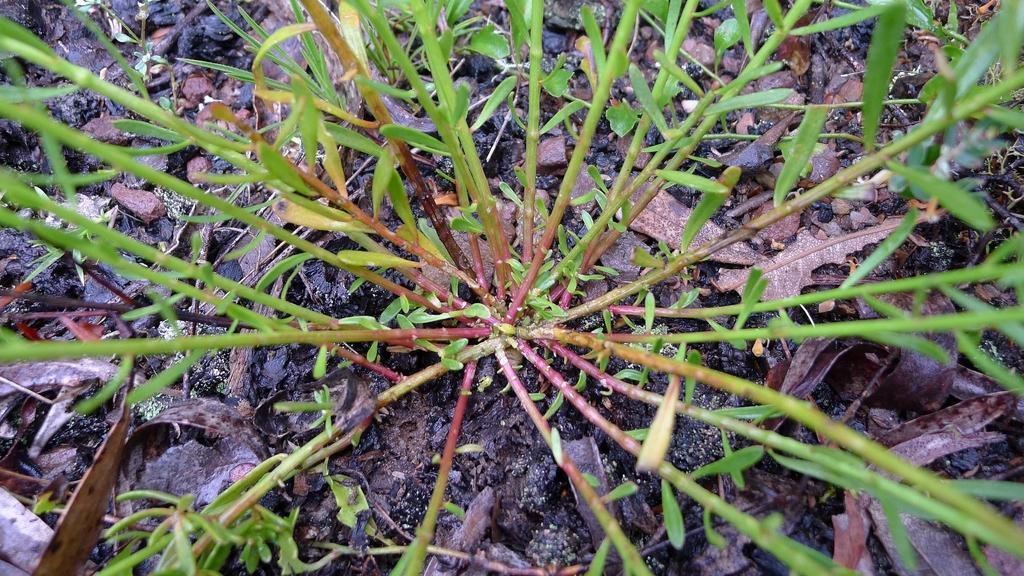In one or two sentences, can you explain what this image depicts? In this image we can see plants and leaves on the ground. 